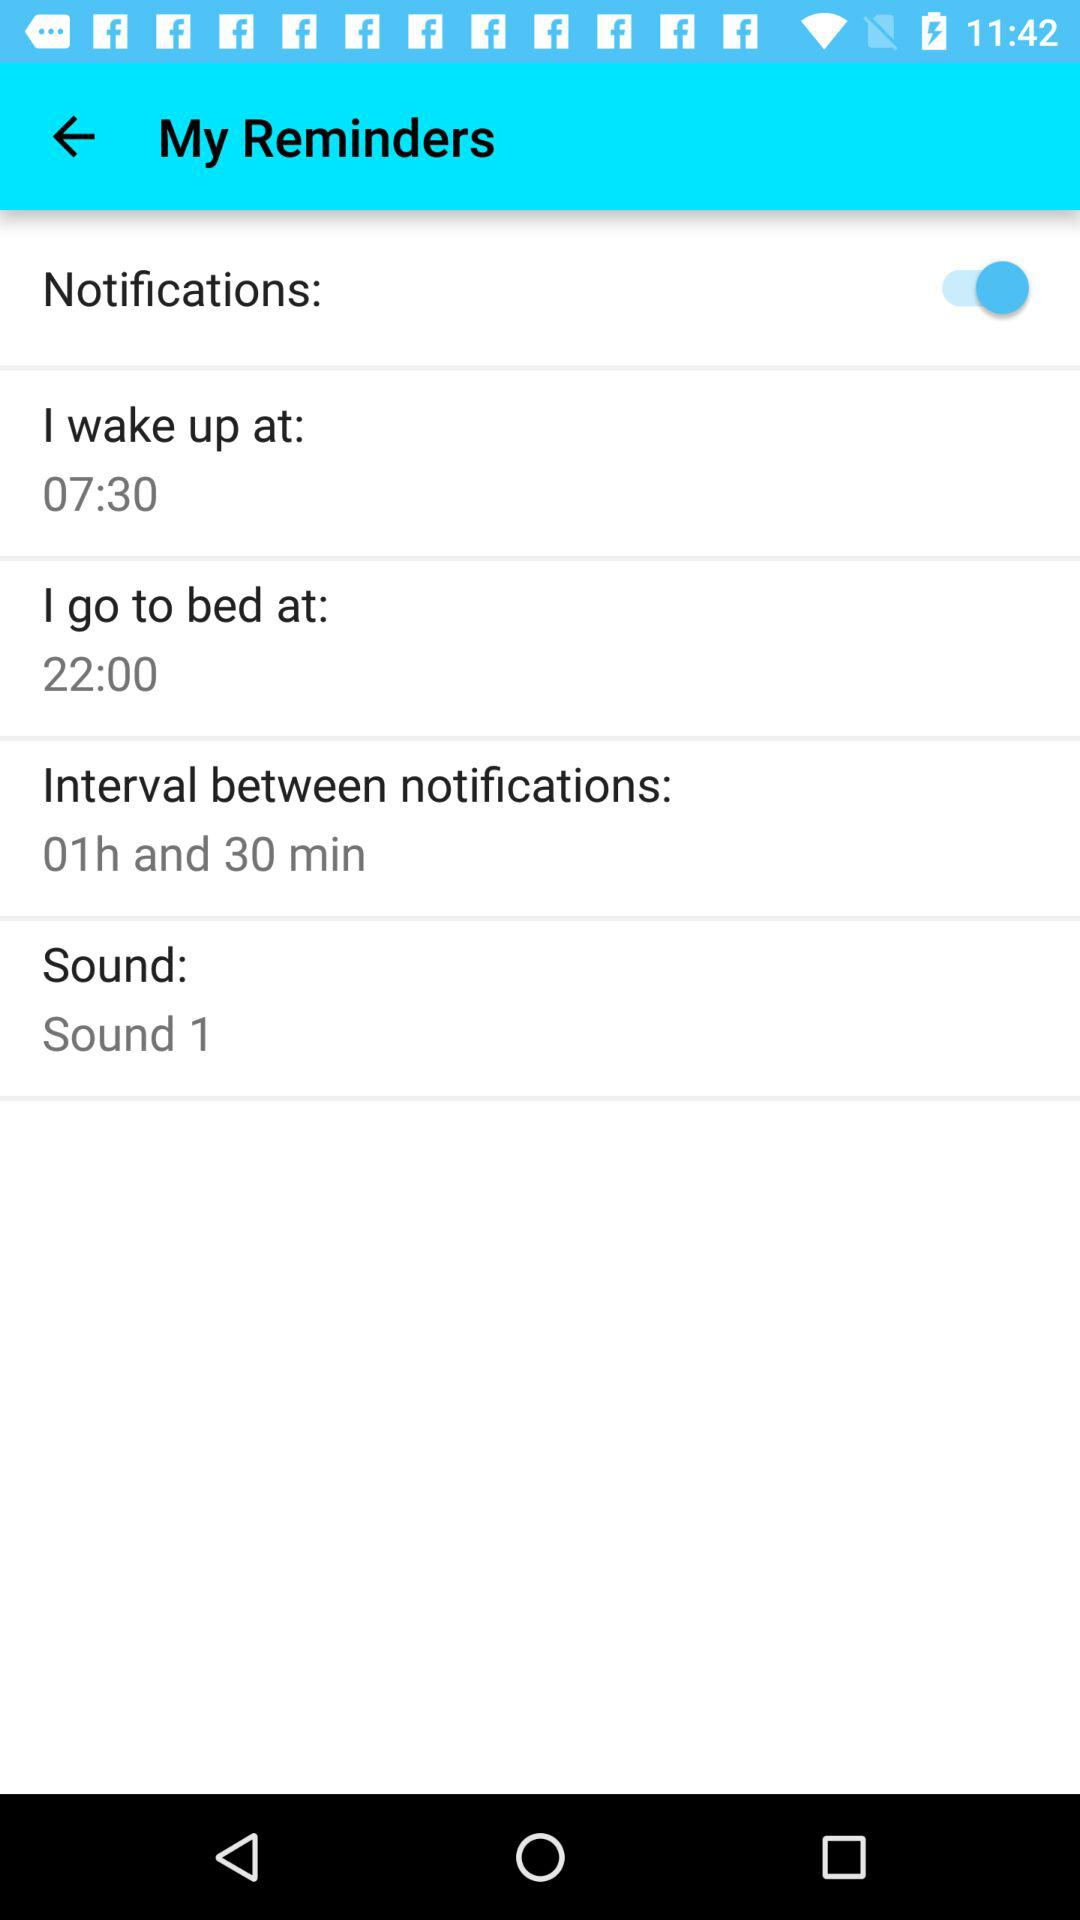What is the selected sound? The selected sound is "Sound 1". 